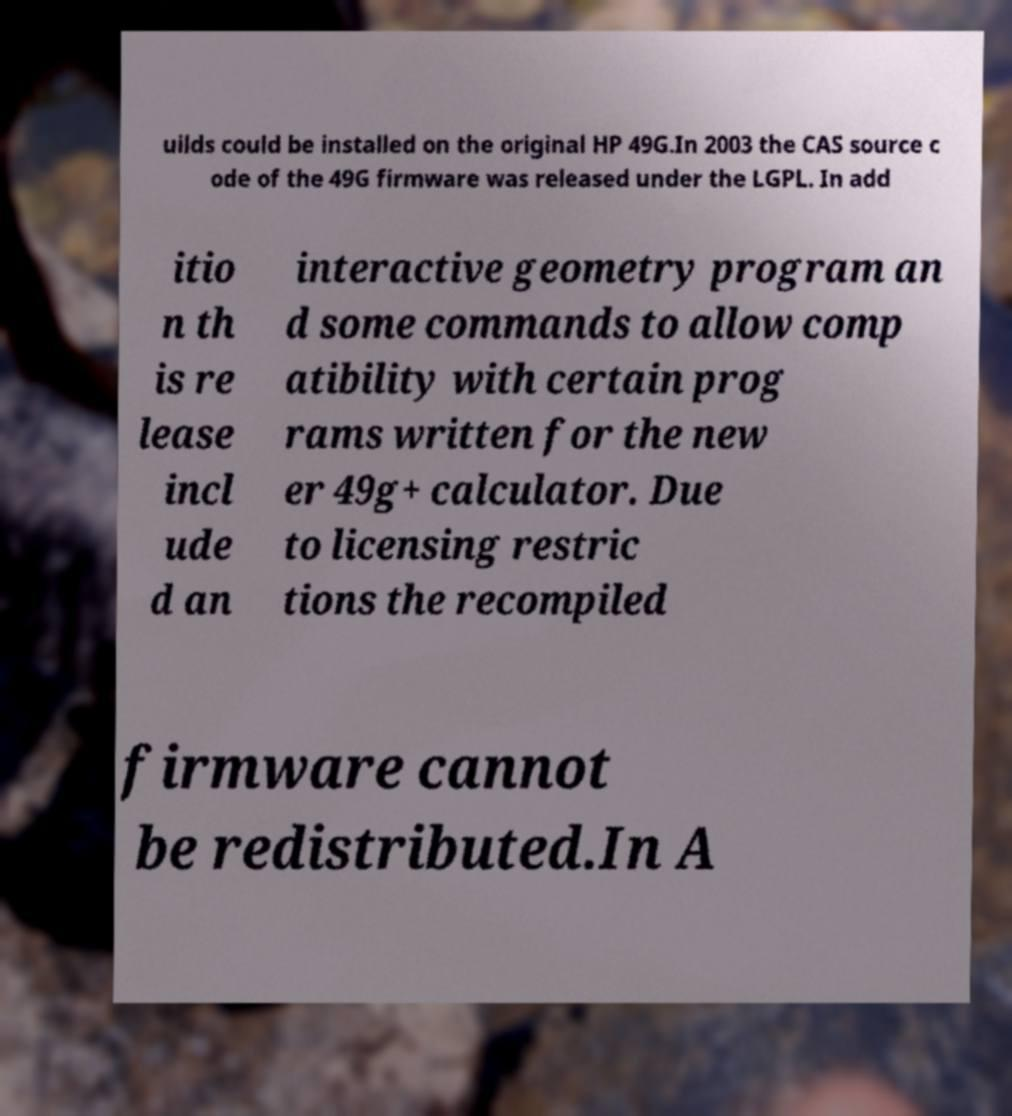Please read and relay the text visible in this image. What does it say? uilds could be installed on the original HP 49G.In 2003 the CAS source c ode of the 49G firmware was released under the LGPL. In add itio n th is re lease incl ude d an interactive geometry program an d some commands to allow comp atibility with certain prog rams written for the new er 49g+ calculator. Due to licensing restric tions the recompiled firmware cannot be redistributed.In A 